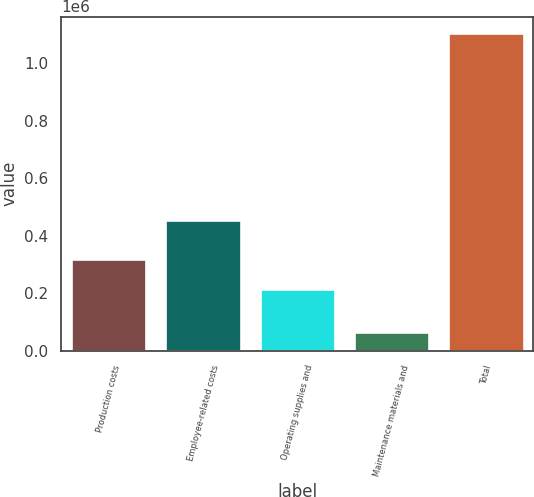Convert chart to OTSL. <chart><loc_0><loc_0><loc_500><loc_500><bar_chart><fcel>Production costs<fcel>Employee-related costs<fcel>Operating supplies and<fcel>Maintenance materials and<fcel>Total<nl><fcel>319661<fcel>455690<fcel>215702<fcel>65853<fcel>1.10544e+06<nl></chart> 